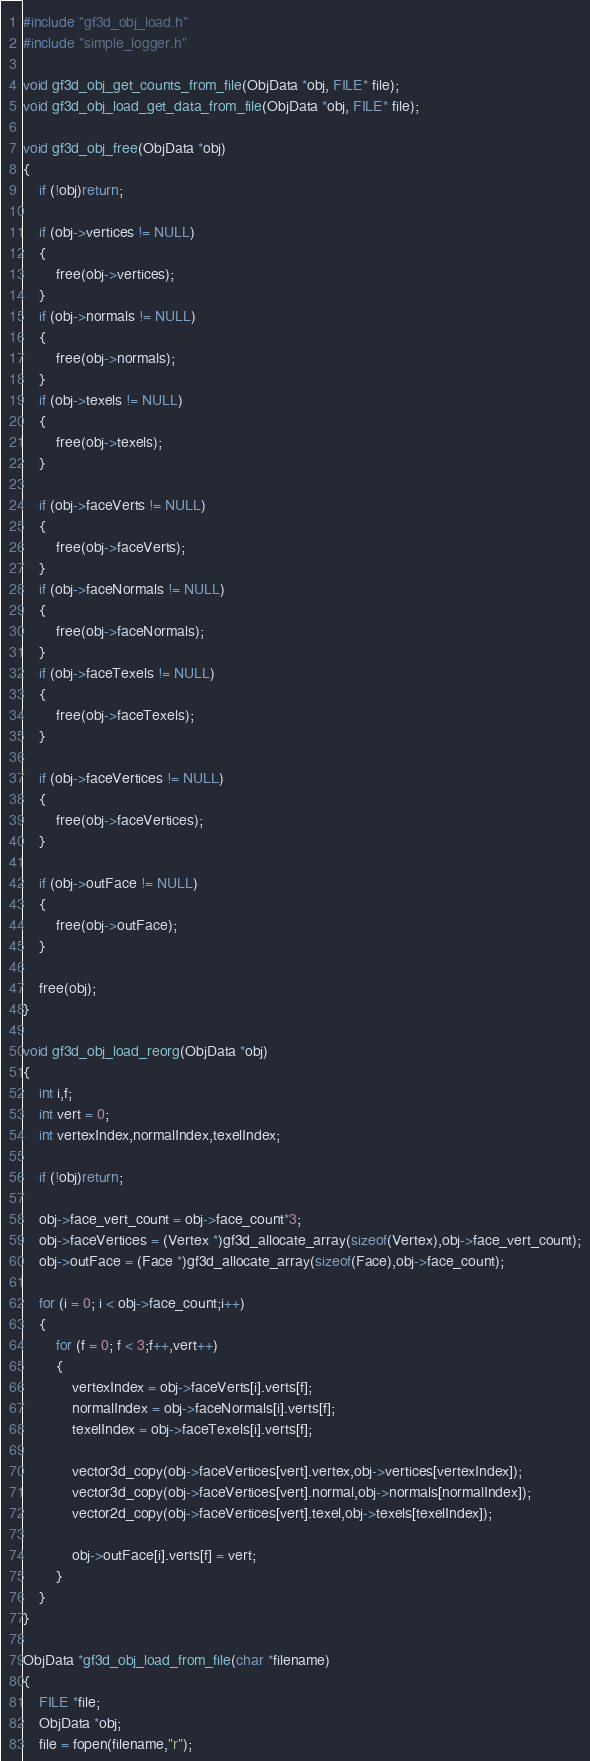Convert code to text. <code><loc_0><loc_0><loc_500><loc_500><_C_>#include "gf3d_obj_load.h"
#include "simple_logger.h"

void gf3d_obj_get_counts_from_file(ObjData *obj, FILE* file);
void gf3d_obj_load_get_data_from_file(ObjData *obj, FILE* file);

void gf3d_obj_free(ObjData *obj)
{
    if (!obj)return;
    
    if (obj->vertices != NULL)
    {
        free(obj->vertices);
    }
    if (obj->normals != NULL)
    {
        free(obj->normals);
    }
    if (obj->texels != NULL)
    {
        free(obj->texels);
    }
    
    if (obj->faceVerts != NULL)
    {
        free(obj->faceVerts);
    }
    if (obj->faceNormals != NULL)
    {
        free(obj->faceNormals);
    }
    if (obj->faceTexels != NULL)
    {
        free(obj->faceTexels);
    }
    
    if (obj->faceVertices != NULL)
    {
        free(obj->faceVertices);
    }
    
    if (obj->outFace != NULL)
    {
        free(obj->outFace);
    }
    
    free(obj);
}

void gf3d_obj_load_reorg(ObjData *obj)
{
    int i,f;
    int vert = 0;
    int vertexIndex,normalIndex,texelIndex;
    
    if (!obj)return;
    
    obj->face_vert_count = obj->face_count*3;
    obj->faceVertices = (Vertex *)gf3d_allocate_array(sizeof(Vertex),obj->face_vert_count);
    obj->outFace = (Face *)gf3d_allocate_array(sizeof(Face),obj->face_count);
    
    for (i = 0; i < obj->face_count;i++)
    {
        for (f = 0; f < 3;f++,vert++)
        {
            vertexIndex = obj->faceVerts[i].verts[f];
            normalIndex = obj->faceNormals[i].verts[f];
            texelIndex = obj->faceTexels[i].verts[f];
            
            vector3d_copy(obj->faceVertices[vert].vertex,obj->vertices[vertexIndex]);
            vector3d_copy(obj->faceVertices[vert].normal,obj->normals[normalIndex]);
            vector2d_copy(obj->faceVertices[vert].texel,obj->texels[texelIndex]);
            
            obj->outFace[i].verts[f] = vert;
        }
    }
}

ObjData *gf3d_obj_load_from_file(char *filename)
{
    FILE *file;
    ObjData *obj;
    file = fopen(filename,"r");</code> 